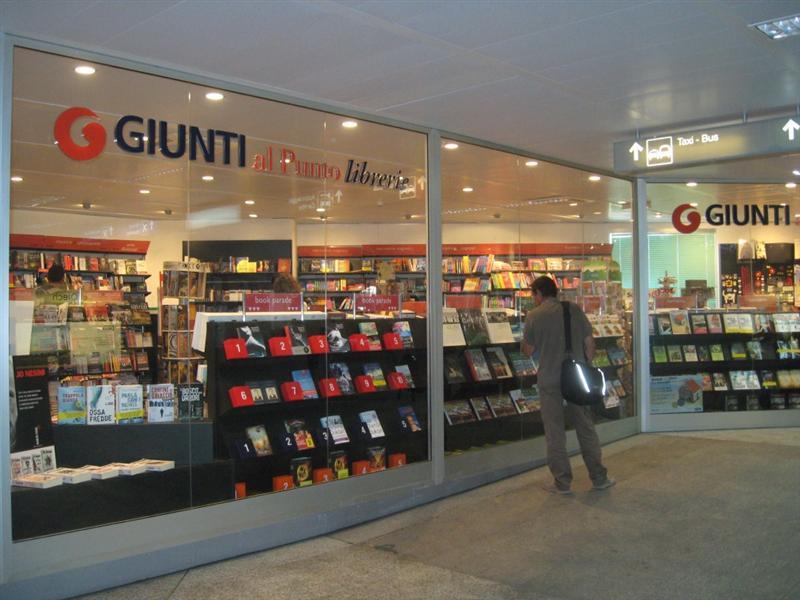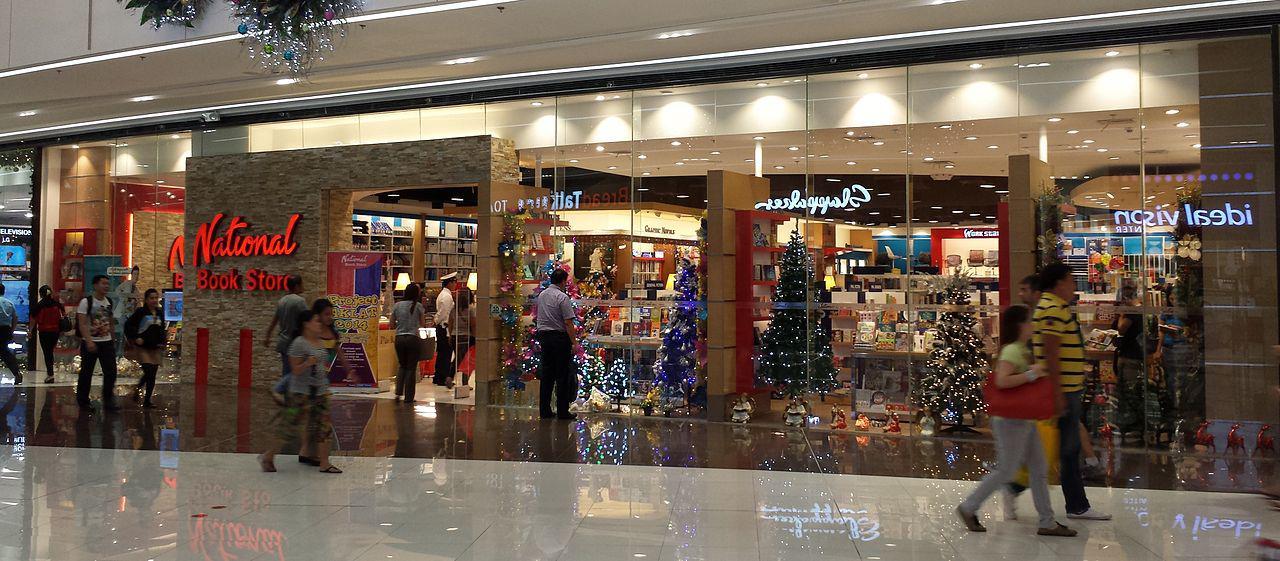The first image is the image on the left, the second image is the image on the right. Evaluate the accuracy of this statement regarding the images: "There are at least two people in the image on the right.". Is it true? Answer yes or no. Yes. 